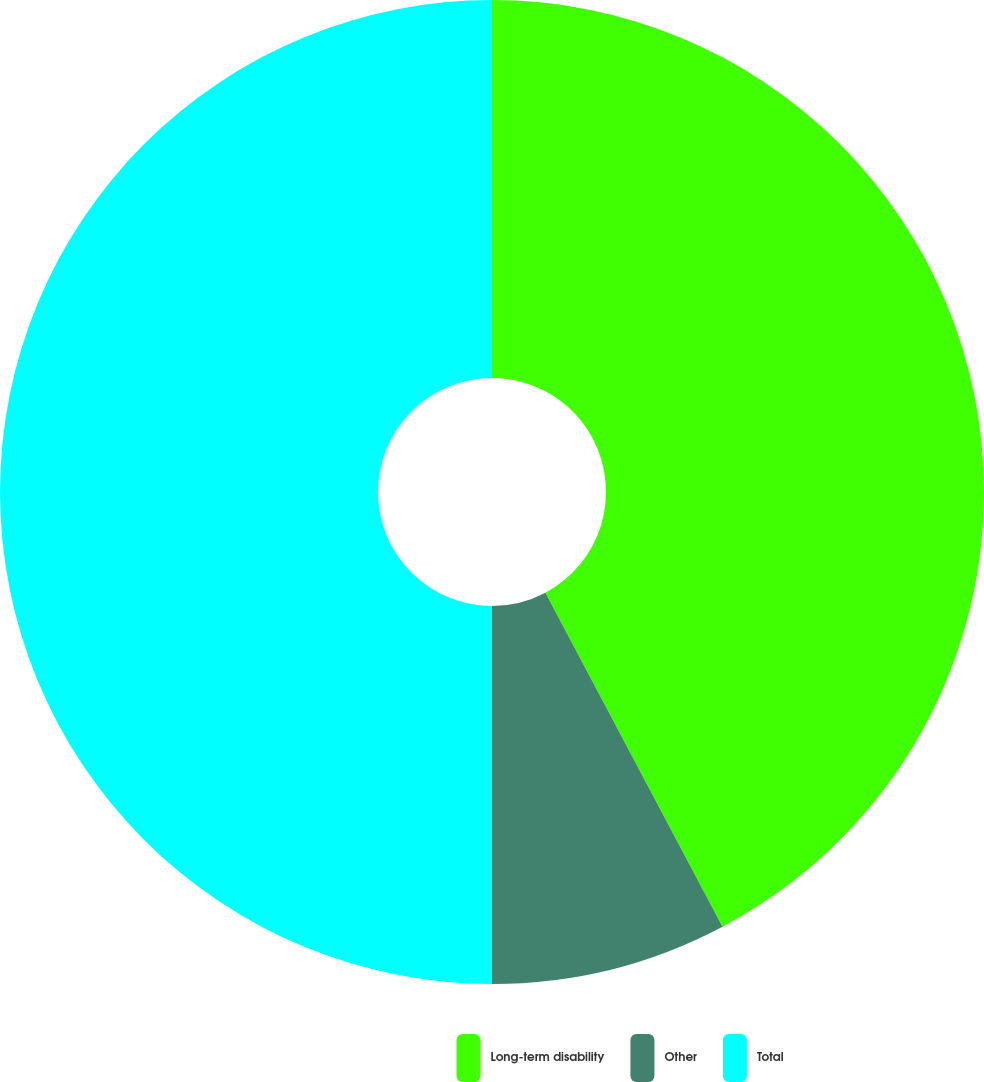Convert chart to OTSL. <chart><loc_0><loc_0><loc_500><loc_500><pie_chart><fcel>Long-term disability<fcel>Other<fcel>Total<nl><fcel>42.24%<fcel>7.76%<fcel>50.0%<nl></chart> 